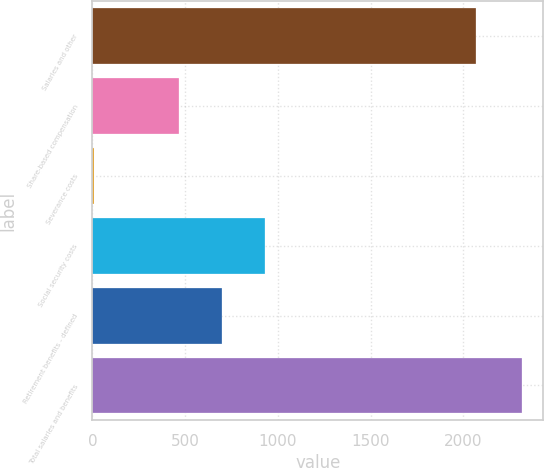<chart> <loc_0><loc_0><loc_500><loc_500><bar_chart><fcel>Salaries and other<fcel>Share-based compensation<fcel>Severance costs<fcel>Social security costs<fcel>Retirement benefits - defined<fcel>Total salaries and benefits<nl><fcel>2069<fcel>469.2<fcel>8<fcel>930.4<fcel>699.8<fcel>2314<nl></chart> 